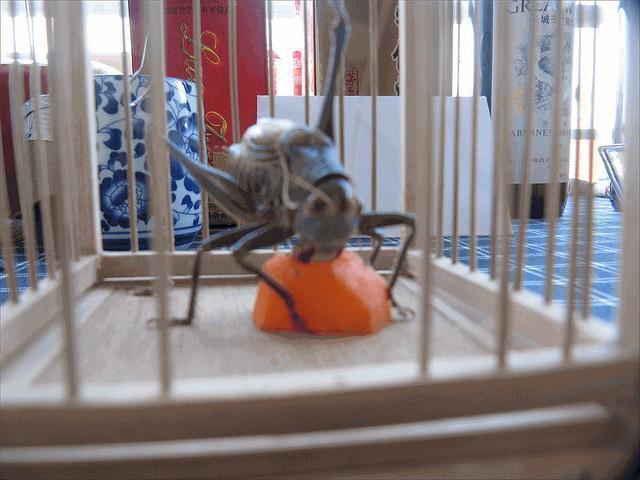What kind of animal do you see in the picture?
Choose the right answer from the provided options to respond to the question.
Options: Insect, fish, mammal, reptile. Insect. 